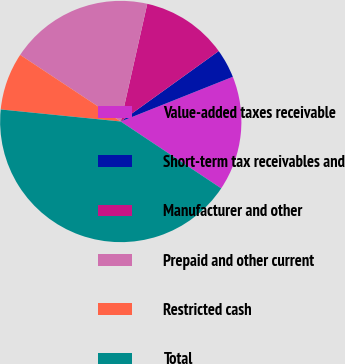<chart> <loc_0><loc_0><loc_500><loc_500><pie_chart><fcel>Value-added taxes receivable<fcel>Short-term tax receivables and<fcel>Manufacturer and other<fcel>Prepaid and other current<fcel>Restricted cash<fcel>Total<nl><fcel>15.39%<fcel>3.88%<fcel>11.55%<fcel>19.22%<fcel>7.72%<fcel>42.24%<nl></chart> 